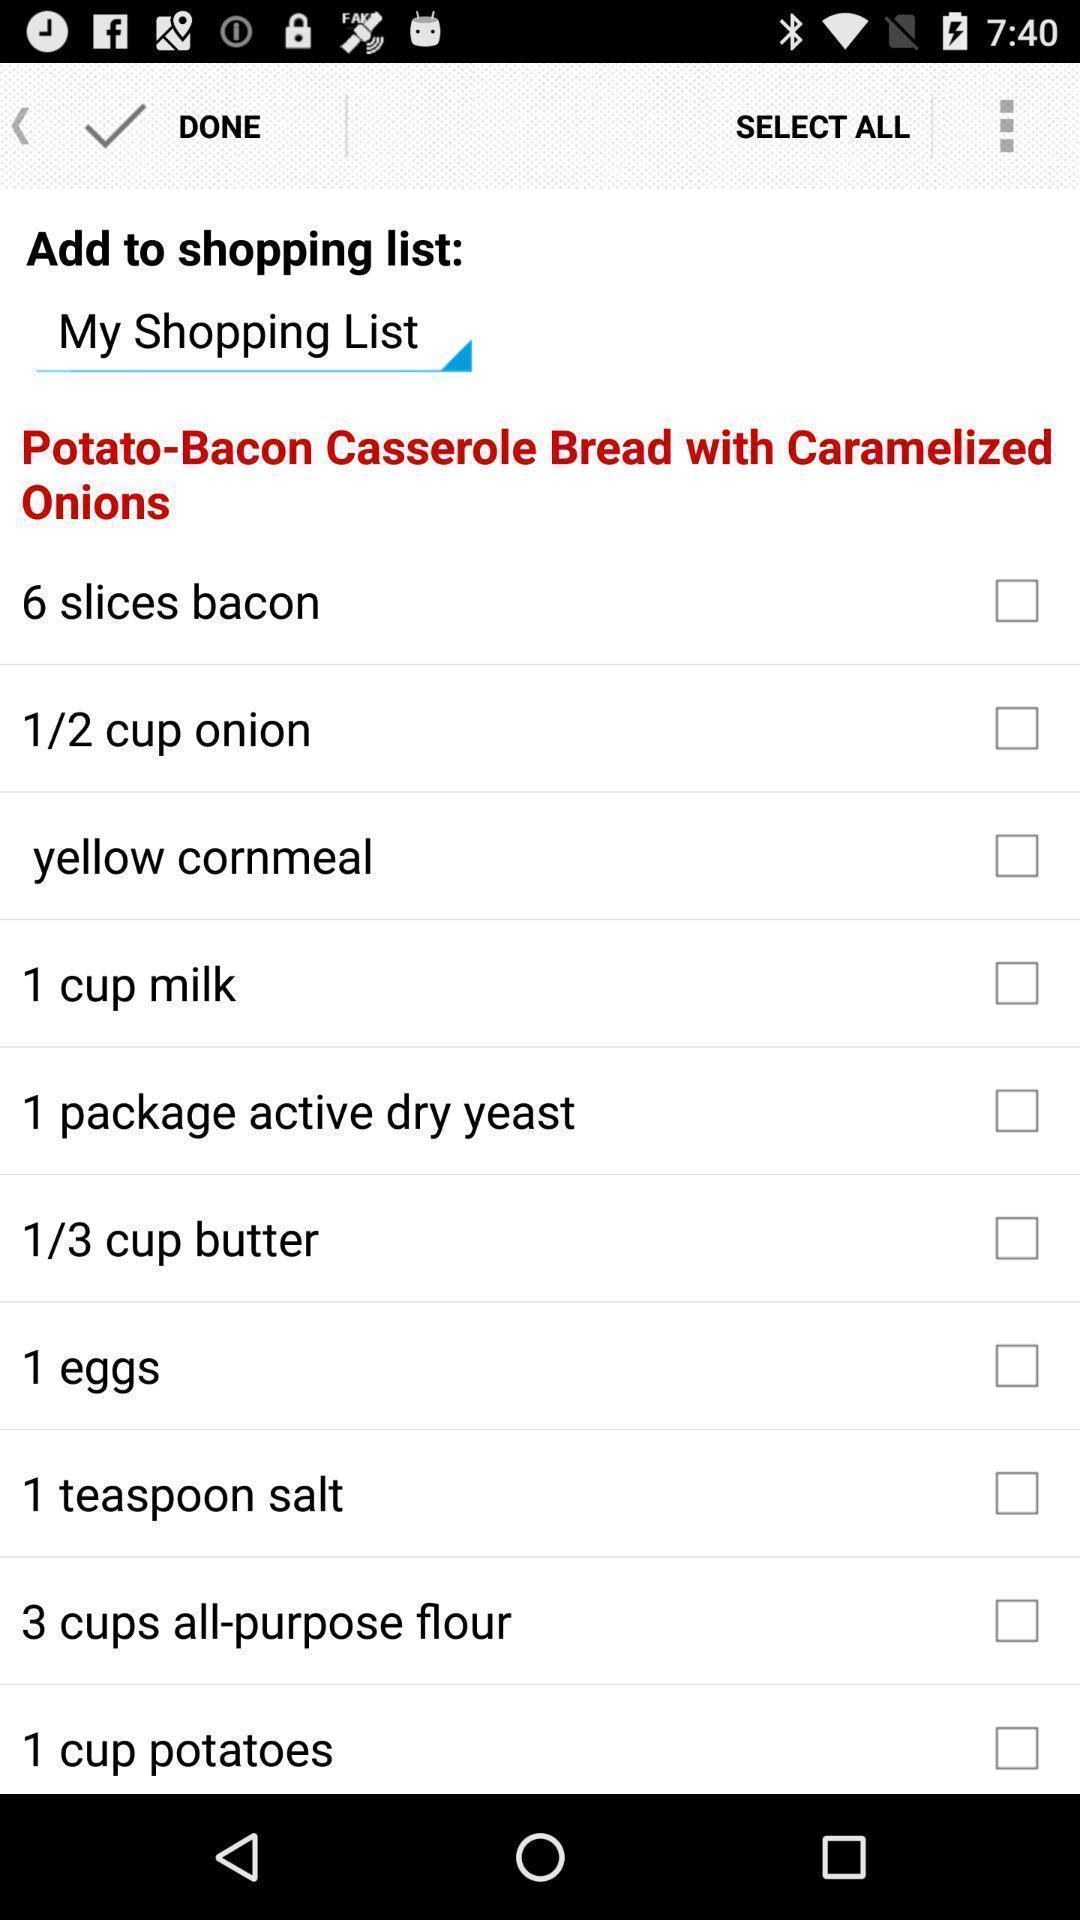Provide a description of this screenshot. Shopping list is available in the app. 